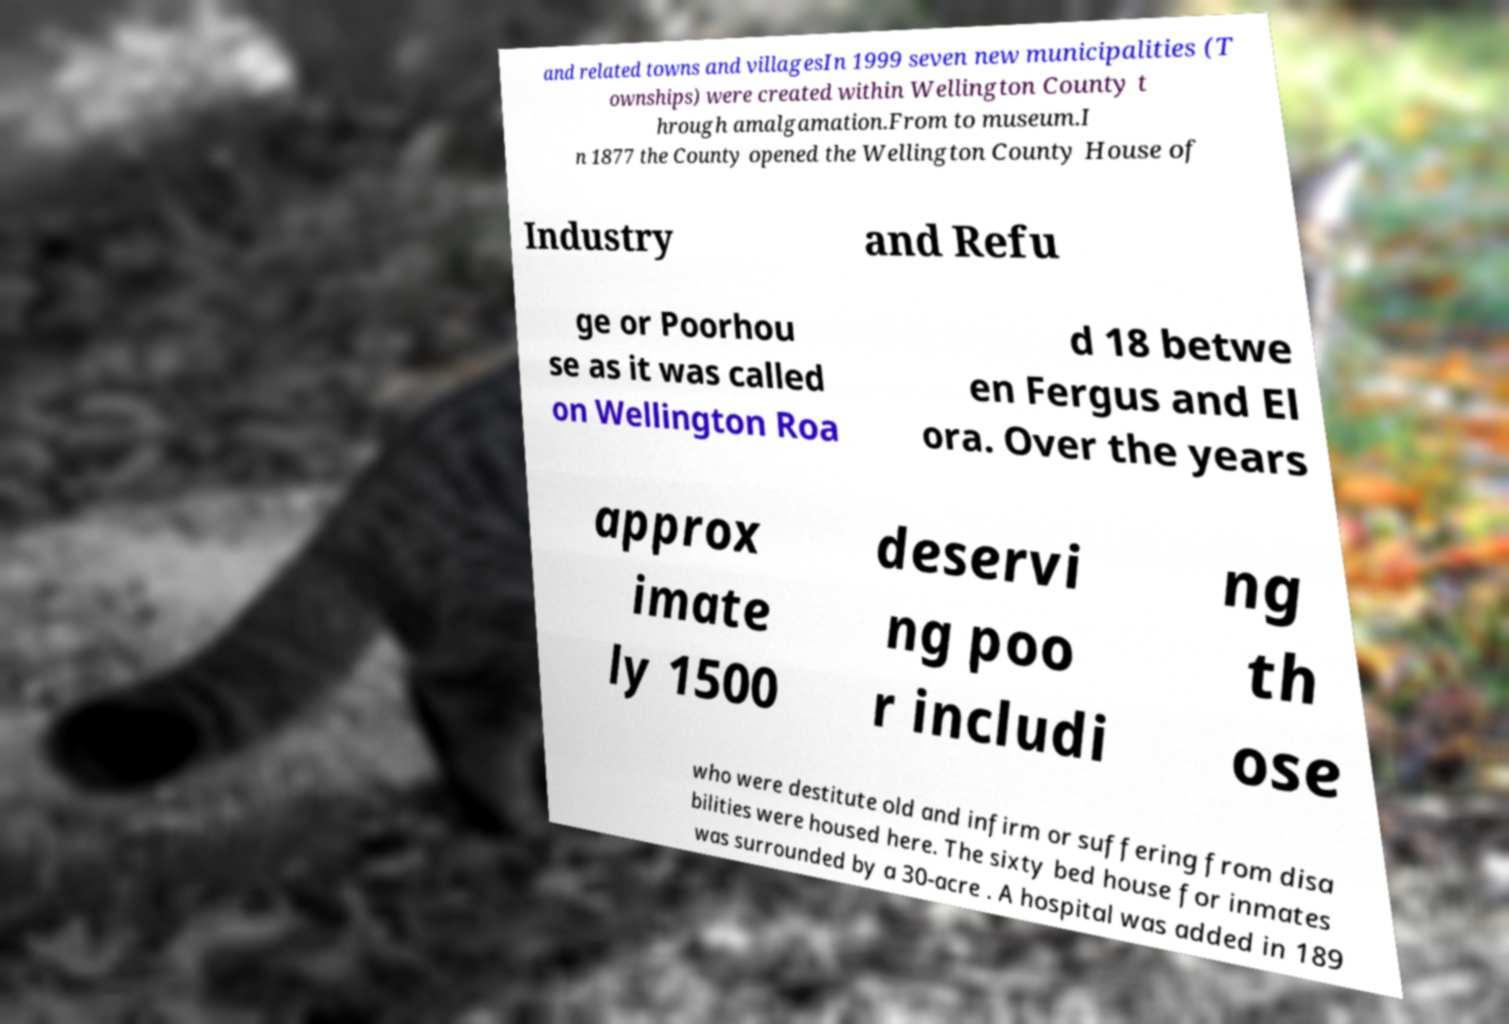Can you accurately transcribe the text from the provided image for me? and related towns and villagesIn 1999 seven new municipalities (T ownships) were created within Wellington County t hrough amalgamation.From to museum.I n 1877 the County opened the Wellington County House of Industry and Refu ge or Poorhou se as it was called on Wellington Roa d 18 betwe en Fergus and El ora. Over the years approx imate ly 1500 deservi ng poo r includi ng th ose who were destitute old and infirm or suffering from disa bilities were housed here. The sixty bed house for inmates was surrounded by a 30-acre . A hospital was added in 189 